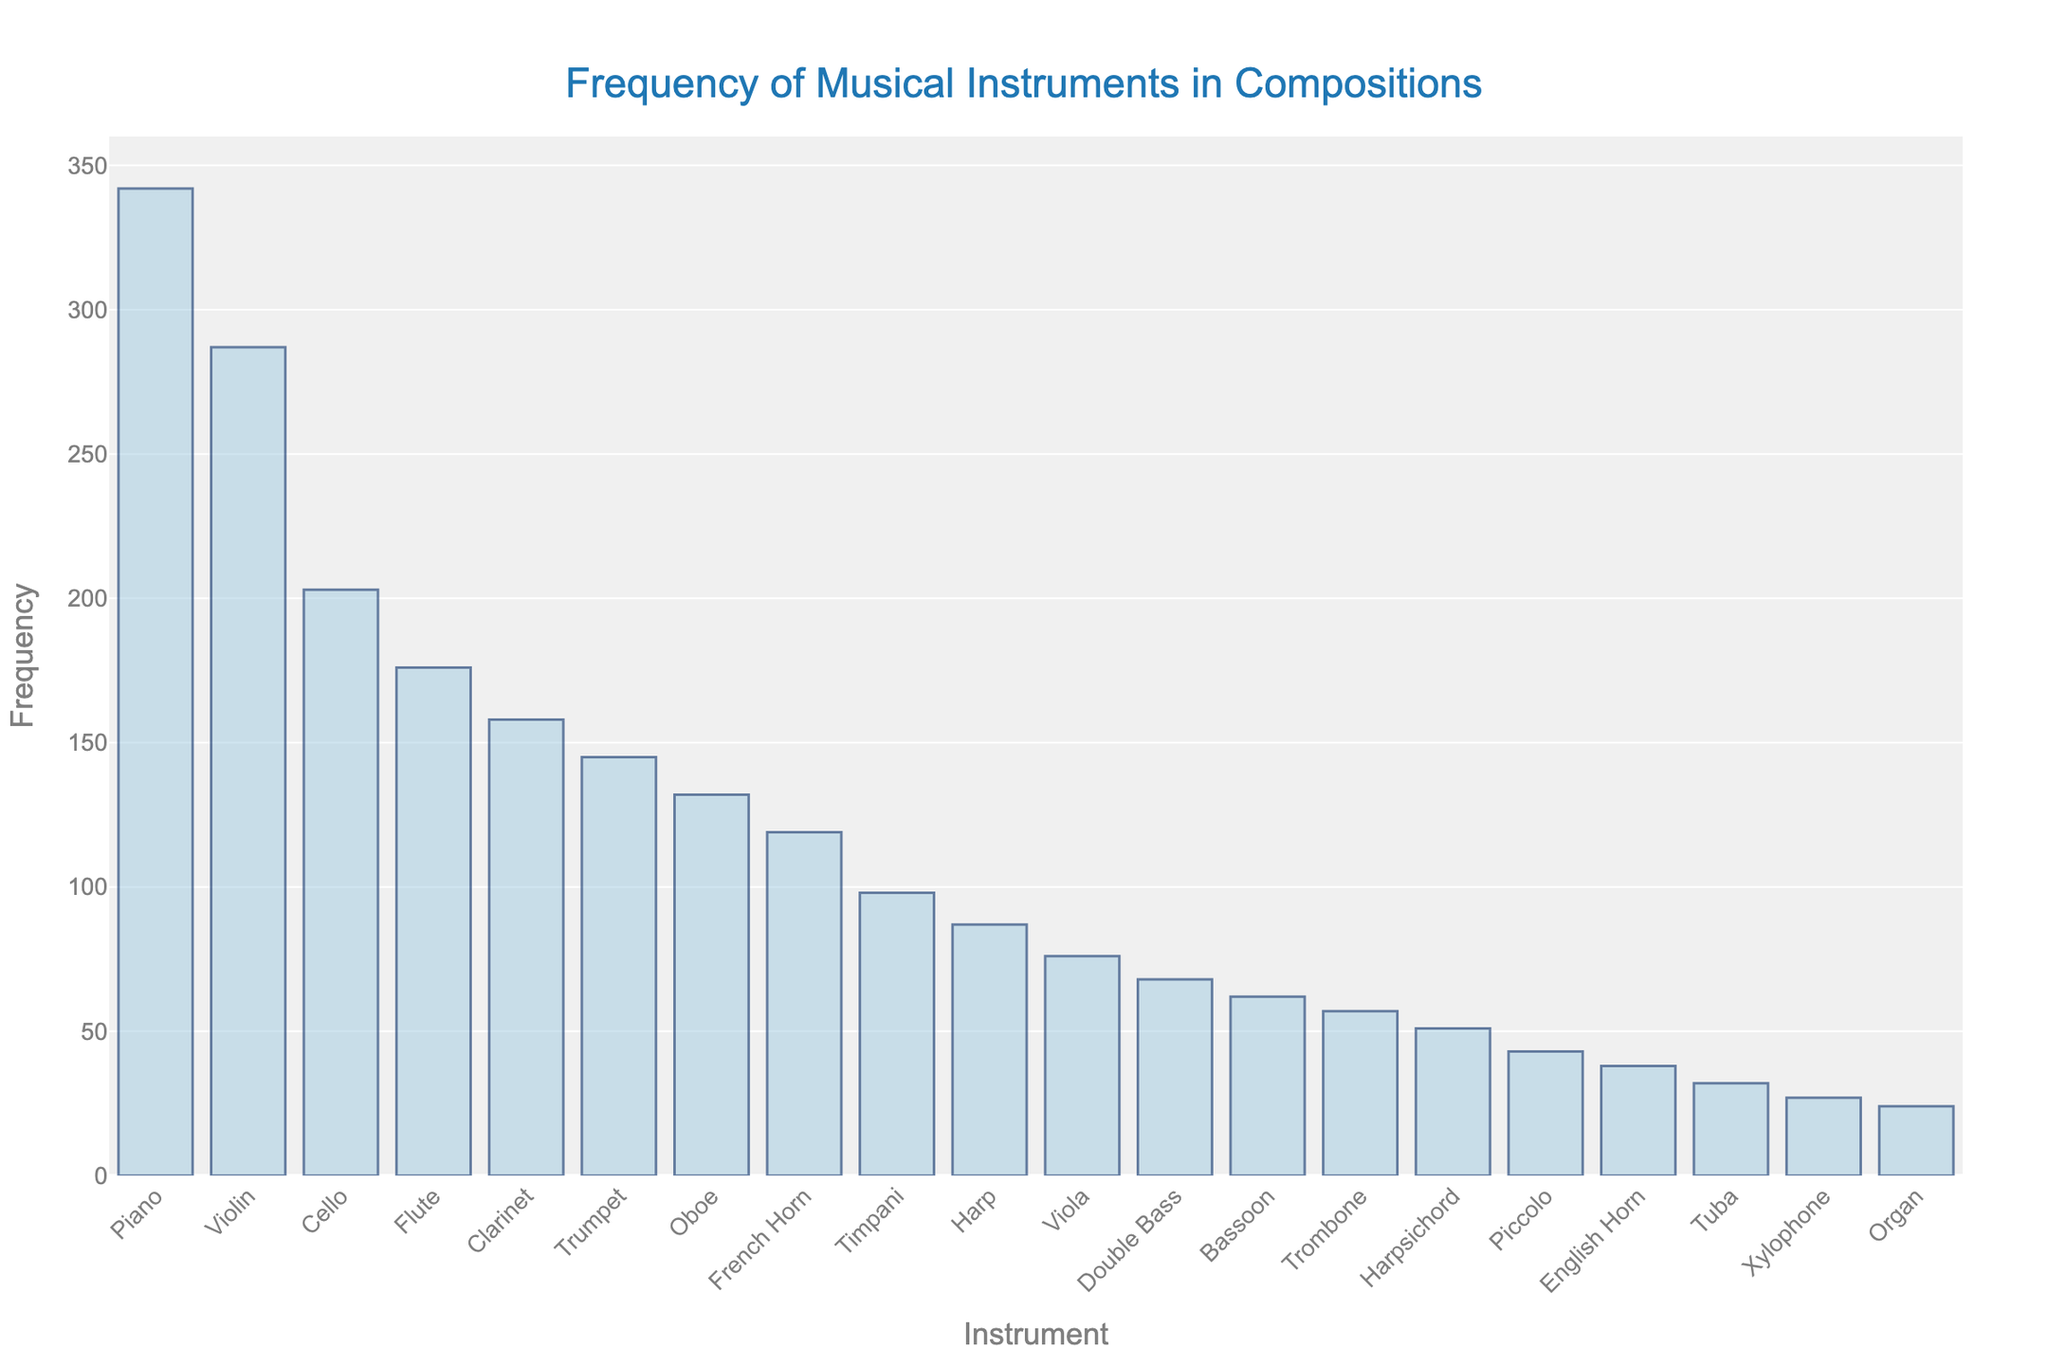What is the most frequently used instrument? The tallest bar in the chart represents the most frequently used instrument. By referring to the chart, the piano bar is the tallest.
Answer: Piano Which instruments have frequencies between 100 and 200? Look for bars whose top edges fall in the range of 100 to 200 on the y-axis. Based on this, the bars for Flute, Clarinet, Trumpet, Oboe, and French Horn fall within this range.
Answer: Flute, Clarinet, Trumpet, Oboe, French Horn How many instruments have a frequency of more than 200? Count the number of bars that extend above the 200 mark on the y-axis. The Piano, Violin, and Cello bars meet this criterion.
Answer: 3 What is the combined frequency of Oboe, French Horn, and Timpani? Find the heights of the Oboe, French Horn, and Timpani bars (132, 119, and 98 respectively), and sum them up: 132 + 119 + 98 = 349.
Answer: 349 Which has a higher frequency: Cello or Flute? Compare the heights of the Cello and Flute bars. The Cello bar is taller at 203 compared to the Flute bar at 176.
Answer: Cello Determine the average frequency of the top three most frequently used instruments. Identify the top three frequencies (342 for Piano, 287 for Violin, and 203 for Cello), and calculate their average: (342 + 287 + 203) / 3 = 944 / 3 ≈ 314.67.
Answer: 314.67 What is the least frequently used instrument? The shortest bar in the chart represents the least frequently used instrument. The Organ bar is the shortest.
Answer: Organ Which instrument is used exactly 76 times? Find the bar whose height corresponds to the value of 76 on the y-axis. The Viola bar matches this frequency.
Answer: Viola By how much does the frequency of the Trumpet exceed that of the Tuba? Subtract the Tuba frequency from the Trumpet frequency: 145 - 32 = 113.
Answer: 113 Is the frequency of the Harp greater than or less than the Harpsichord’s frequency? Compare the heights of the Harp and Harpsichord bars. The Harp bar, at 87, is taller than the Harpsichord bar, which is at 51.
Answer: Greater 